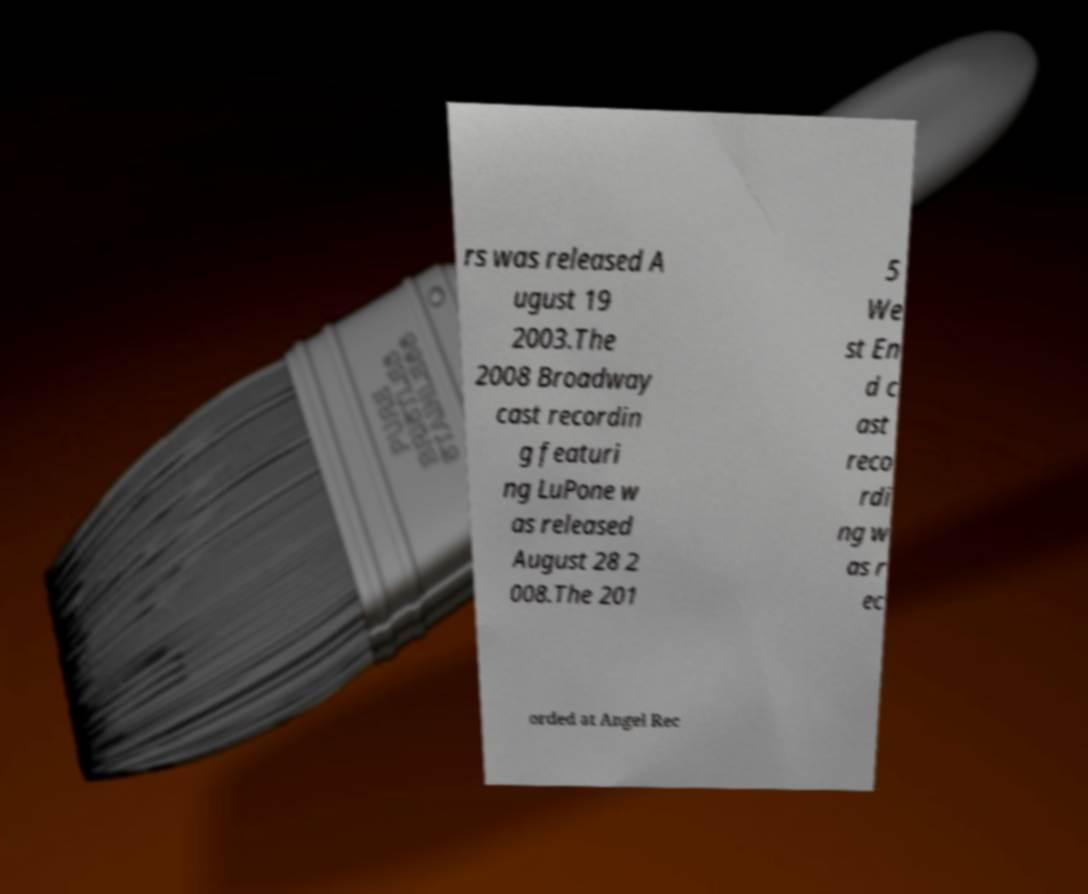Please read and relay the text visible in this image. What does it say? rs was released A ugust 19 2003.The 2008 Broadway cast recordin g featuri ng LuPone w as released August 28 2 008.The 201 5 We st En d c ast reco rdi ng w as r ec orded at Angel Rec 